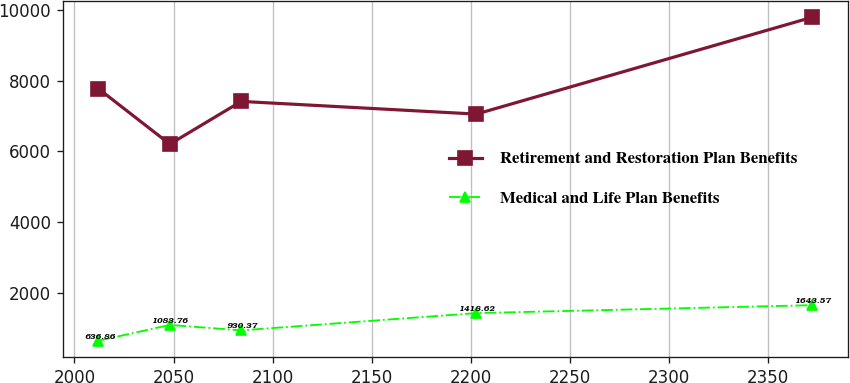Convert chart. <chart><loc_0><loc_0><loc_500><loc_500><line_chart><ecel><fcel>Retirement and Restoration Plan Benefits<fcel>Medical and Life Plan Benefits<nl><fcel>2012.11<fcel>7773.19<fcel>636.86<nl><fcel>2048.14<fcel>6203.35<fcel>1083.76<nl><fcel>2084.17<fcel>7413.87<fcel>930.37<nl><fcel>2202.87<fcel>7054.55<fcel>1418.62<nl><fcel>2372.43<fcel>9796.55<fcel>1643.57<nl></chart> 